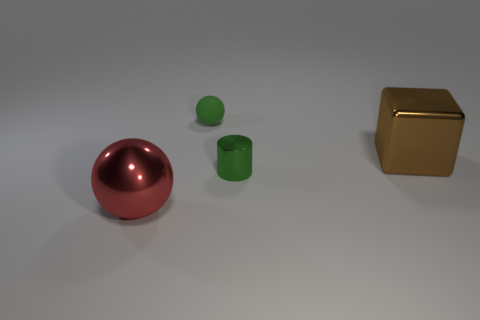Add 2 large green balls. How many objects exist? 6 Subtract all cylinders. How many objects are left? 3 Subtract all green rubber balls. Subtract all brown shiny things. How many objects are left? 2 Add 2 shiny balls. How many shiny balls are left? 3 Add 2 large shiny spheres. How many large shiny spheres exist? 3 Subtract 0 cyan cylinders. How many objects are left? 4 